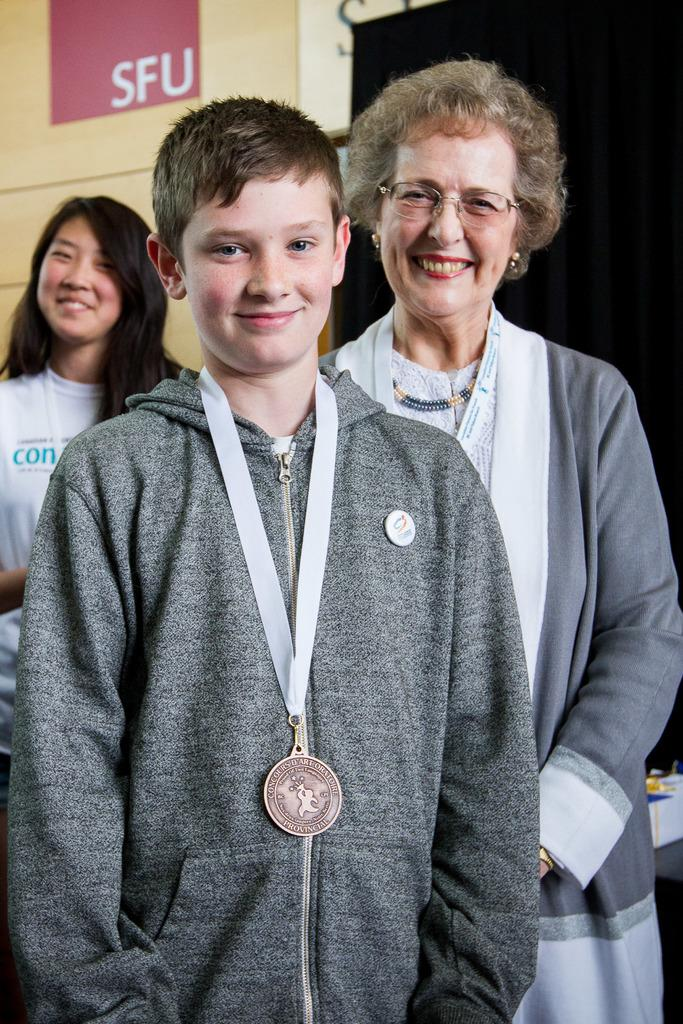How many people are in the image? There are three persons in the image. What are the persons wearing? The persons are wearing clothes. Can you describe the person in the middle of the image? The person in the middle of the image is wearing a medal. What is visible in the top left of the image? There is a wall visible in the top left of the image. What type of guitar is the person in the image playing? There is no guitar present in the image; the persons are not playing any musical instruments. 